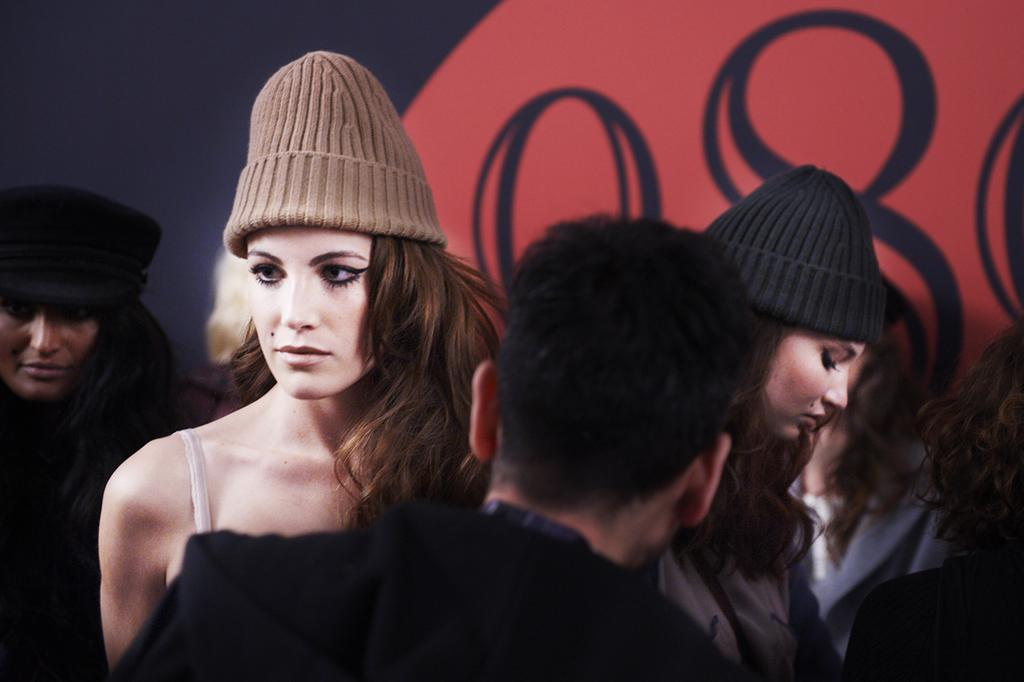What is happening in the image? There are people standing in the image. What can be seen in the background of the image? There is a hoarding in the background of the image. What colors are used for the hoarding? The hoarding is red and black in color. How many bags are being carried by the people in the image? There is no information about bags being carried by the people in the image. What type of furniture is visible in the image? There is no furniture visible in the image; it only shows people standing and a hoarding in the background. 